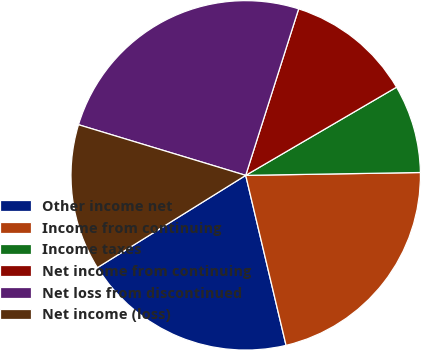Convert chart to OTSL. <chart><loc_0><loc_0><loc_500><loc_500><pie_chart><fcel>Other income net<fcel>Income from continuing<fcel>Income taxes<fcel>Net income from continuing<fcel>Net loss from discontinued<fcel>Net income (loss)<nl><fcel>19.85%<fcel>21.55%<fcel>8.16%<fcel>11.68%<fcel>25.22%<fcel>13.54%<nl></chart> 